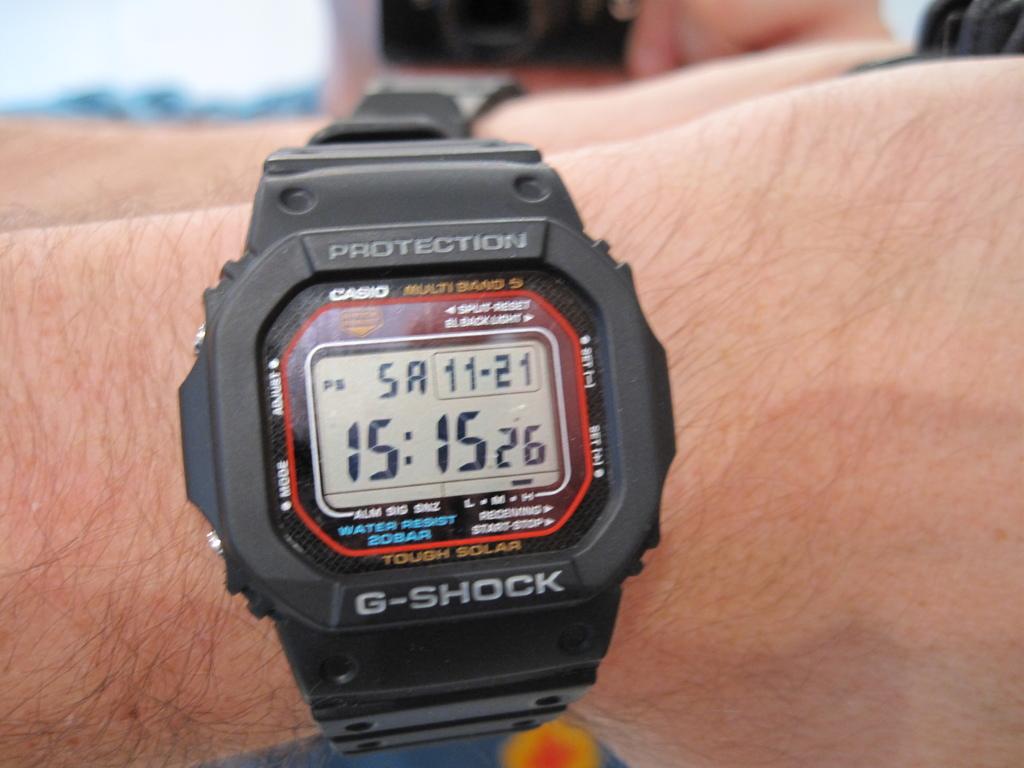What is the date?
Offer a very short reply. 11-21. What time does the watch say it is?
Give a very brief answer. 15:15. 